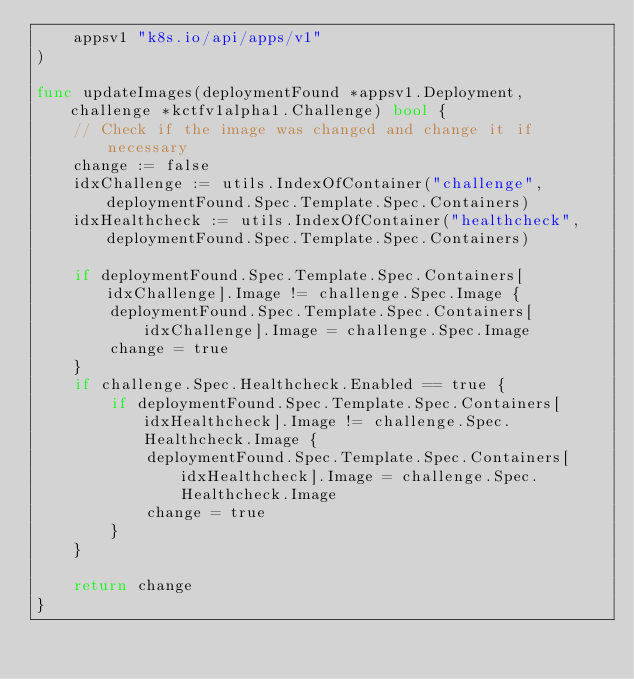Convert code to text. <code><loc_0><loc_0><loc_500><loc_500><_Go_>	appsv1 "k8s.io/api/apps/v1"
)

func updateImages(deploymentFound *appsv1.Deployment, challenge *kctfv1alpha1.Challenge) bool {
	// Check if the image was changed and change it if necessary
	change := false
	idxChallenge := utils.IndexOfContainer("challenge", deploymentFound.Spec.Template.Spec.Containers)
	idxHealthcheck := utils.IndexOfContainer("healthcheck", deploymentFound.Spec.Template.Spec.Containers)

	if deploymentFound.Spec.Template.Spec.Containers[idxChallenge].Image != challenge.Spec.Image {
		deploymentFound.Spec.Template.Spec.Containers[idxChallenge].Image = challenge.Spec.Image
		change = true
	}
	if challenge.Spec.Healthcheck.Enabled == true {
		if deploymentFound.Spec.Template.Spec.Containers[idxHealthcheck].Image != challenge.Spec.Healthcheck.Image {
			deploymentFound.Spec.Template.Spec.Containers[idxHealthcheck].Image = challenge.Spec.Healthcheck.Image
			change = true
		}
	}

	return change
}
</code> 